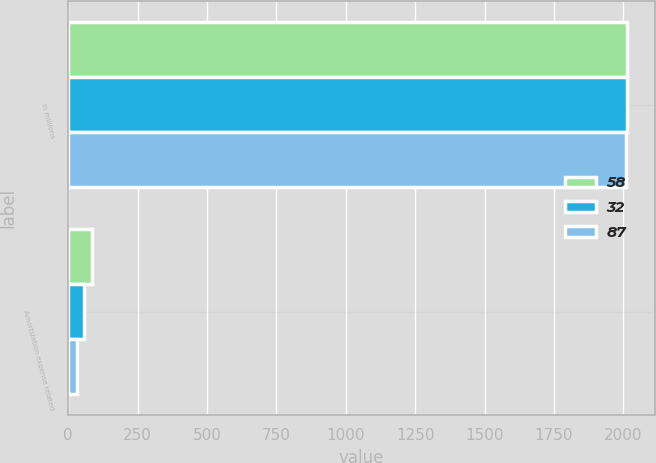<chart> <loc_0><loc_0><loc_500><loc_500><stacked_bar_chart><ecel><fcel>In millions<fcel>Amortization expense related<nl><fcel>58<fcel>2013<fcel>87<nl><fcel>32<fcel>2012<fcel>58<nl><fcel>87<fcel>2011<fcel>32<nl></chart> 